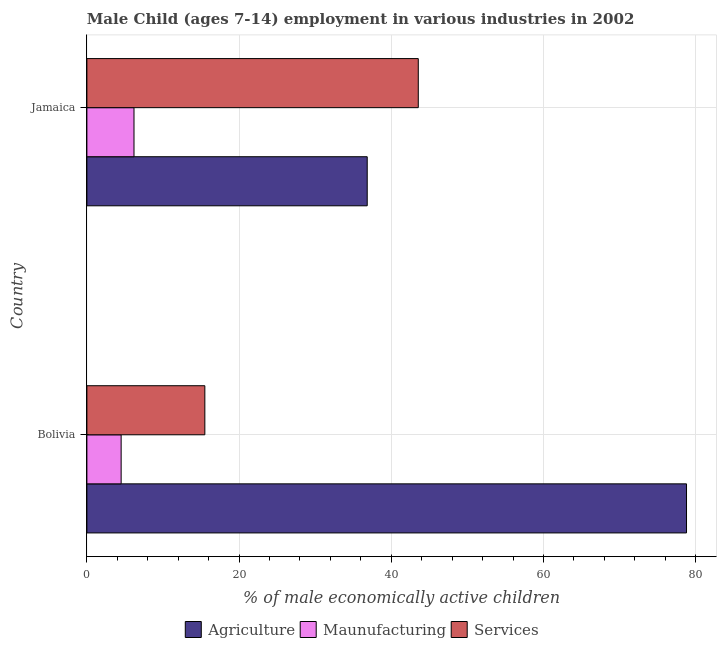How many different coloured bars are there?
Offer a very short reply. 3. How many groups of bars are there?
Ensure brevity in your answer.  2. Are the number of bars on each tick of the Y-axis equal?
Provide a short and direct response. Yes. How many bars are there on the 2nd tick from the top?
Provide a succinct answer. 3. What is the label of the 2nd group of bars from the top?
Keep it short and to the point. Bolivia. What is the percentage of economically active children in manufacturing in Jamaica?
Offer a terse response. 6.19. Across all countries, what is the maximum percentage of economically active children in services?
Provide a short and direct response. 43.55. Across all countries, what is the minimum percentage of economically active children in agriculture?
Your answer should be compact. 36.84. In which country was the percentage of economically active children in services maximum?
Make the answer very short. Jamaica. In which country was the percentage of economically active children in manufacturing minimum?
Offer a very short reply. Bolivia. What is the total percentage of economically active children in services in the graph?
Provide a short and direct response. 59.05. What is the difference between the percentage of economically active children in agriculture in Bolivia and that in Jamaica?
Your response must be concise. 41.96. What is the difference between the percentage of economically active children in agriculture in Bolivia and the percentage of economically active children in manufacturing in Jamaica?
Provide a succinct answer. 72.61. What is the average percentage of economically active children in manufacturing per country?
Your response must be concise. 5.34. What is the difference between the percentage of economically active children in agriculture and percentage of economically active children in manufacturing in Jamaica?
Provide a succinct answer. 30.65. In how many countries, is the percentage of economically active children in agriculture greater than 72 %?
Your answer should be compact. 1. What is the ratio of the percentage of economically active children in services in Bolivia to that in Jamaica?
Make the answer very short. 0.36. Is the difference between the percentage of economically active children in manufacturing in Bolivia and Jamaica greater than the difference between the percentage of economically active children in services in Bolivia and Jamaica?
Provide a succinct answer. Yes. In how many countries, is the percentage of economically active children in agriculture greater than the average percentage of economically active children in agriculture taken over all countries?
Offer a terse response. 1. What does the 1st bar from the top in Jamaica represents?
Your response must be concise. Services. What does the 1st bar from the bottom in Jamaica represents?
Provide a short and direct response. Agriculture. Are all the bars in the graph horizontal?
Your response must be concise. Yes. How many countries are there in the graph?
Provide a short and direct response. 2. Does the graph contain any zero values?
Give a very brief answer. No. Where does the legend appear in the graph?
Make the answer very short. Bottom center. How are the legend labels stacked?
Make the answer very short. Horizontal. What is the title of the graph?
Provide a succinct answer. Male Child (ages 7-14) employment in various industries in 2002. What is the label or title of the X-axis?
Offer a very short reply. % of male economically active children. What is the label or title of the Y-axis?
Your answer should be very brief. Country. What is the % of male economically active children of Agriculture in Bolivia?
Provide a short and direct response. 78.8. What is the % of male economically active children of Services in Bolivia?
Offer a very short reply. 15.5. What is the % of male economically active children of Agriculture in Jamaica?
Offer a very short reply. 36.84. What is the % of male economically active children of Maunufacturing in Jamaica?
Provide a short and direct response. 6.19. What is the % of male economically active children of Services in Jamaica?
Keep it short and to the point. 43.55. Across all countries, what is the maximum % of male economically active children of Agriculture?
Give a very brief answer. 78.8. Across all countries, what is the maximum % of male economically active children in Maunufacturing?
Keep it short and to the point. 6.19. Across all countries, what is the maximum % of male economically active children in Services?
Ensure brevity in your answer.  43.55. Across all countries, what is the minimum % of male economically active children in Agriculture?
Provide a short and direct response. 36.84. What is the total % of male economically active children in Agriculture in the graph?
Your answer should be very brief. 115.64. What is the total % of male economically active children of Maunufacturing in the graph?
Keep it short and to the point. 10.69. What is the total % of male economically active children of Services in the graph?
Provide a succinct answer. 59.05. What is the difference between the % of male economically active children in Agriculture in Bolivia and that in Jamaica?
Your answer should be compact. 41.96. What is the difference between the % of male economically active children of Maunufacturing in Bolivia and that in Jamaica?
Your answer should be very brief. -1.69. What is the difference between the % of male economically active children in Services in Bolivia and that in Jamaica?
Keep it short and to the point. -28.05. What is the difference between the % of male economically active children of Agriculture in Bolivia and the % of male economically active children of Maunufacturing in Jamaica?
Provide a succinct answer. 72.61. What is the difference between the % of male economically active children in Agriculture in Bolivia and the % of male economically active children in Services in Jamaica?
Offer a terse response. 35.25. What is the difference between the % of male economically active children of Maunufacturing in Bolivia and the % of male economically active children of Services in Jamaica?
Your response must be concise. -39.05. What is the average % of male economically active children in Agriculture per country?
Your answer should be very brief. 57.82. What is the average % of male economically active children in Maunufacturing per country?
Offer a very short reply. 5.34. What is the average % of male economically active children of Services per country?
Keep it short and to the point. 29.52. What is the difference between the % of male economically active children of Agriculture and % of male economically active children of Maunufacturing in Bolivia?
Provide a short and direct response. 74.3. What is the difference between the % of male economically active children of Agriculture and % of male economically active children of Services in Bolivia?
Your answer should be very brief. 63.3. What is the difference between the % of male economically active children of Agriculture and % of male economically active children of Maunufacturing in Jamaica?
Provide a short and direct response. 30.65. What is the difference between the % of male economically active children of Agriculture and % of male economically active children of Services in Jamaica?
Provide a short and direct response. -6.71. What is the difference between the % of male economically active children of Maunufacturing and % of male economically active children of Services in Jamaica?
Give a very brief answer. -37.36. What is the ratio of the % of male economically active children of Agriculture in Bolivia to that in Jamaica?
Keep it short and to the point. 2.14. What is the ratio of the % of male economically active children in Maunufacturing in Bolivia to that in Jamaica?
Your response must be concise. 0.73. What is the ratio of the % of male economically active children of Services in Bolivia to that in Jamaica?
Your answer should be very brief. 0.36. What is the difference between the highest and the second highest % of male economically active children in Agriculture?
Give a very brief answer. 41.96. What is the difference between the highest and the second highest % of male economically active children in Maunufacturing?
Keep it short and to the point. 1.69. What is the difference between the highest and the second highest % of male economically active children in Services?
Ensure brevity in your answer.  28.05. What is the difference between the highest and the lowest % of male economically active children in Agriculture?
Offer a very short reply. 41.96. What is the difference between the highest and the lowest % of male economically active children of Maunufacturing?
Make the answer very short. 1.69. What is the difference between the highest and the lowest % of male economically active children in Services?
Your response must be concise. 28.05. 